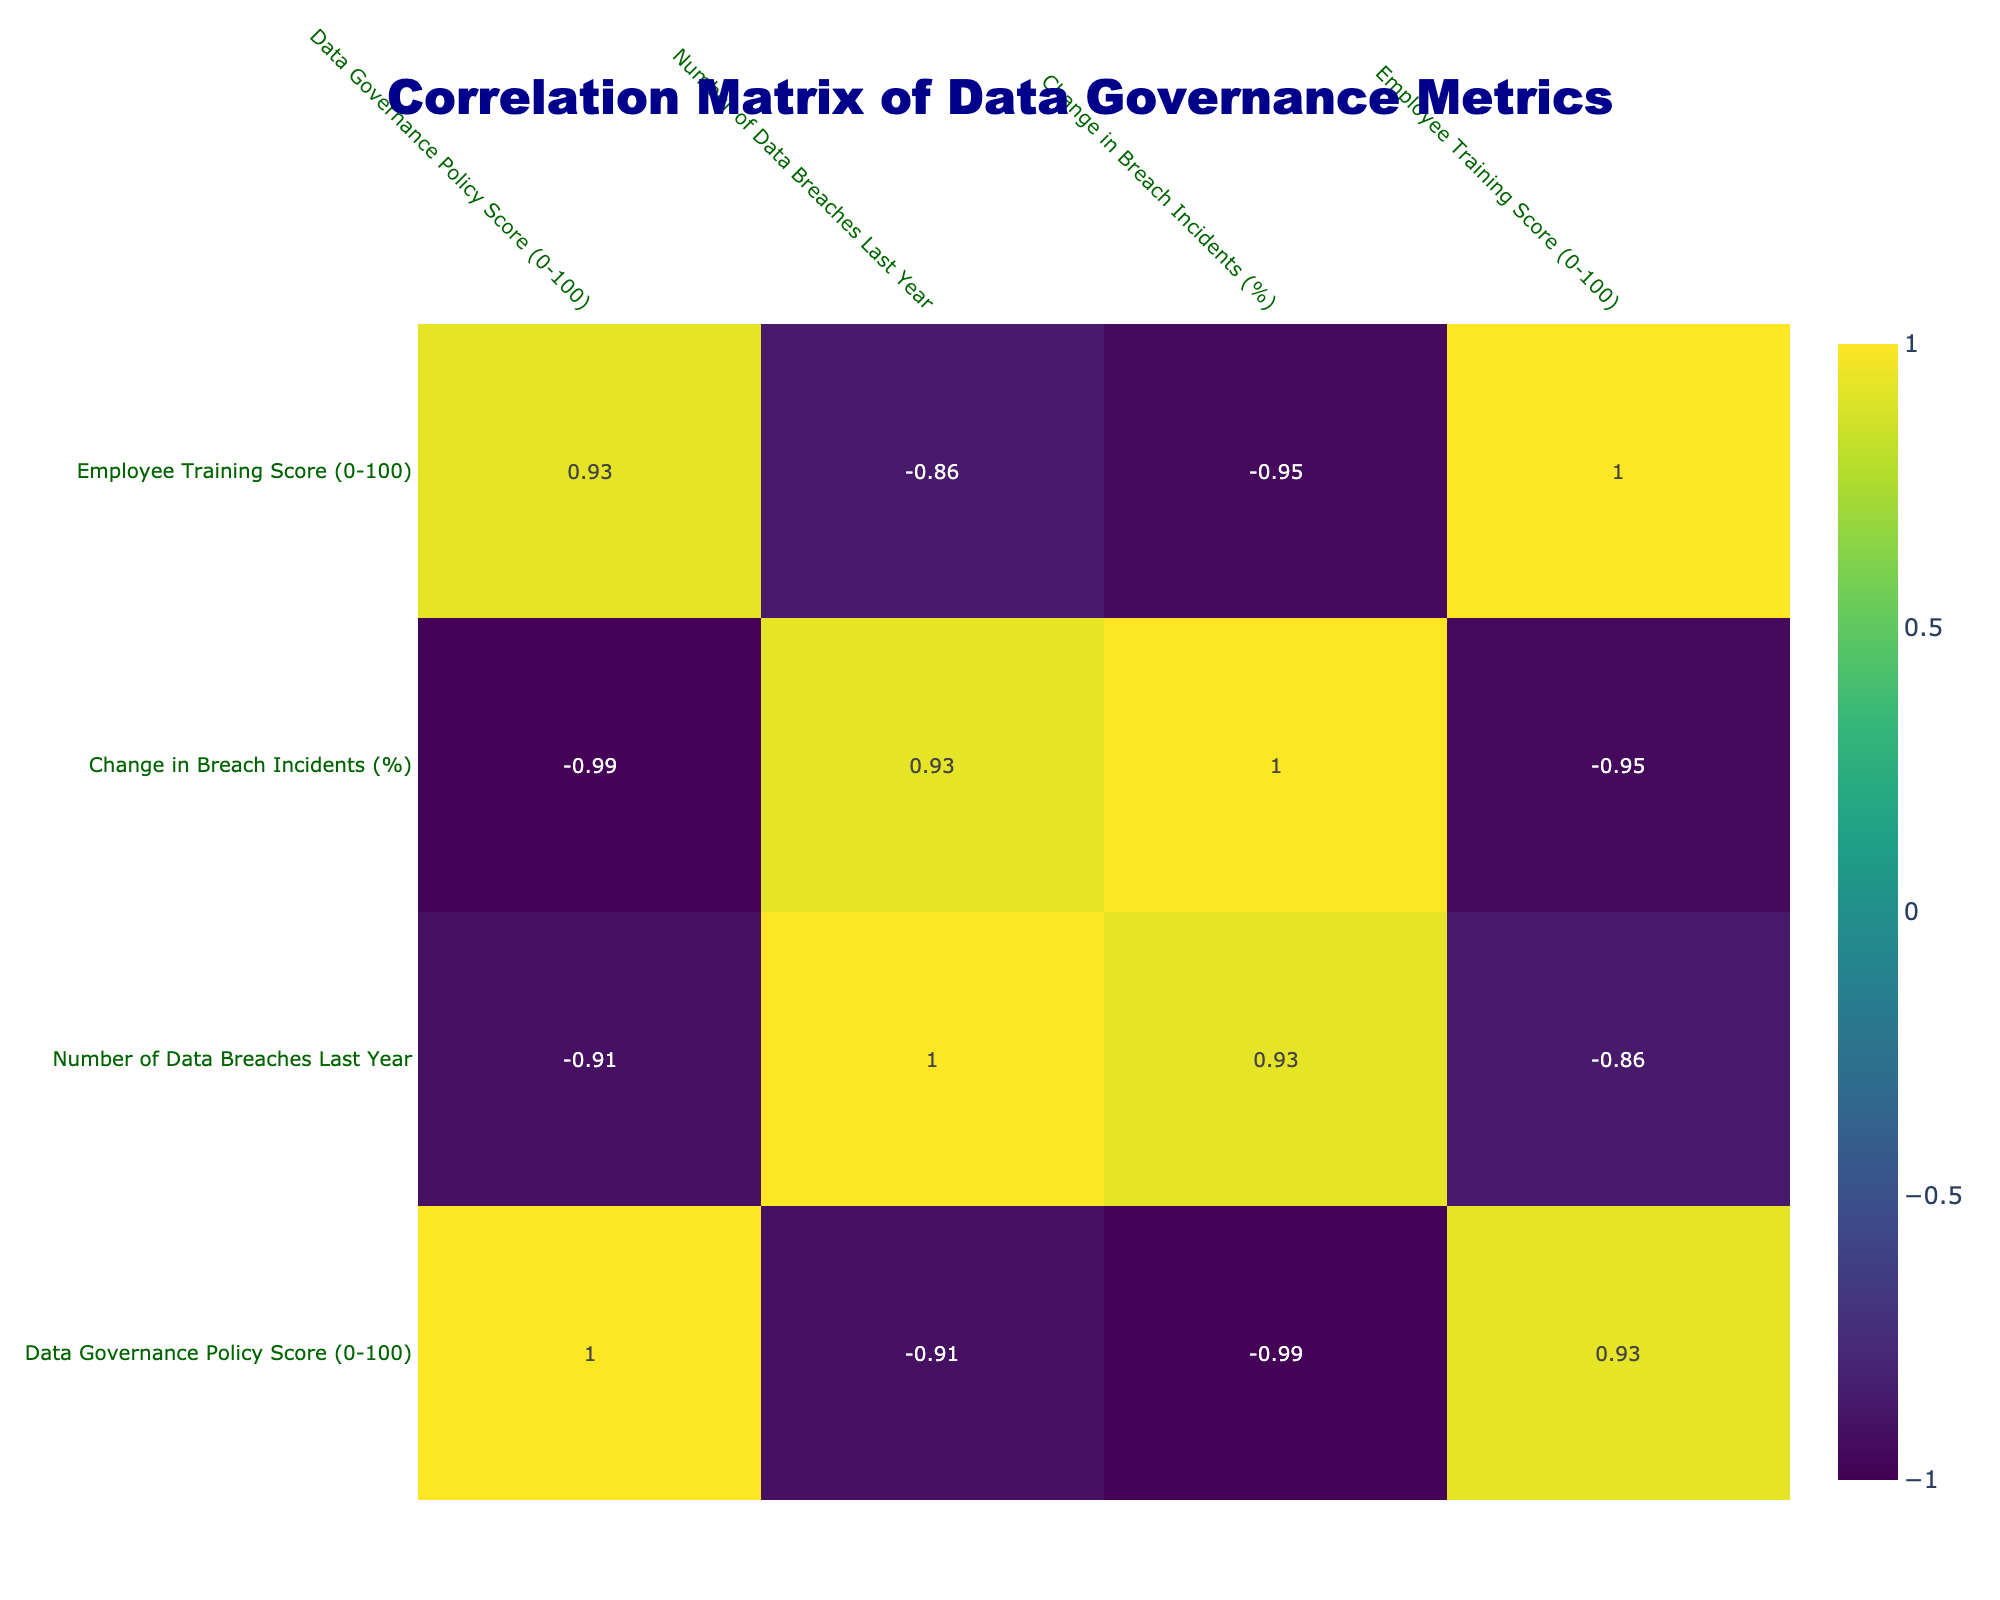What is the Data Governance Policy Score for Apple? The Data Governance Policy Score for Apple is found directly in the table under the corresponding column for Apple. It shows a score of 92.
Answer: 92 Which organization had the fewest data breaches last year? Looking across the "Number of Data Breaches Last Year" column, Apple has the lowest number at 1.
Answer: Apple What is the average change in breach incidents for all organizations? To find the average change in breach incidents, we sum the values in the "Change in Breach Incidents (%)" column and divide by the number of organizations. The sum is (-15 - 25 + 10 - 20 - 30 + 5 + 10 + 20 + 0) = -45. Dividing by 10 gives an average of -4.5%.
Answer: -4.5% Is there a correlation between the Data Governance Policy Score and the number of data breaches last year? To determine if there is correlation, observe the correlation coefficient in the corresponding matrix cell. It suggests a negative correlation coefficient of approximately -0.89, indicating that higher governance scores generally relate to fewer breaches.
Answer: Yes, there is a negative correlation Which organization did not provide encryption and how many data breaches did they have? The "Use of Encryption" column indicates that both Facebook and Uber did not use encryption. Referring to their row in the "Number of Data Breaches Last Year" column, Facebook had 8 breaches and Uber had 10 breaches.
Answer: Facebook (8), Uber (10) If an organization has a Data Governance Policy Score of 85, what can we predict about their number of data breaches? By examining the scores and corresponding number of data breaches with a score of 85, we can look at organizations such as Amazon (5 breaches) and Salesforce (6 breaches). This implies that similar organizations could expect around 5 to 6 data breaches based on this range.
Answer: Approximately 5 to 6 breaches How does the Employee Training Score correlate with the Data Governance Policy Score? The correlation between these columns can be analyzed by looking at the table; they share a high correlation coefficient of around 0.78, indicating that organizations investing in training also tend to have better governance policies.
Answer: Yes, there is a positive correlation What are the data breaches reported by organizations with a policy score above 90? From the table, the organizations with scores above 90 are Google (2 breaches) and Apple (1 breach). Adding these together, the total number of reported breaches is 3.
Answer: 3 breaches 